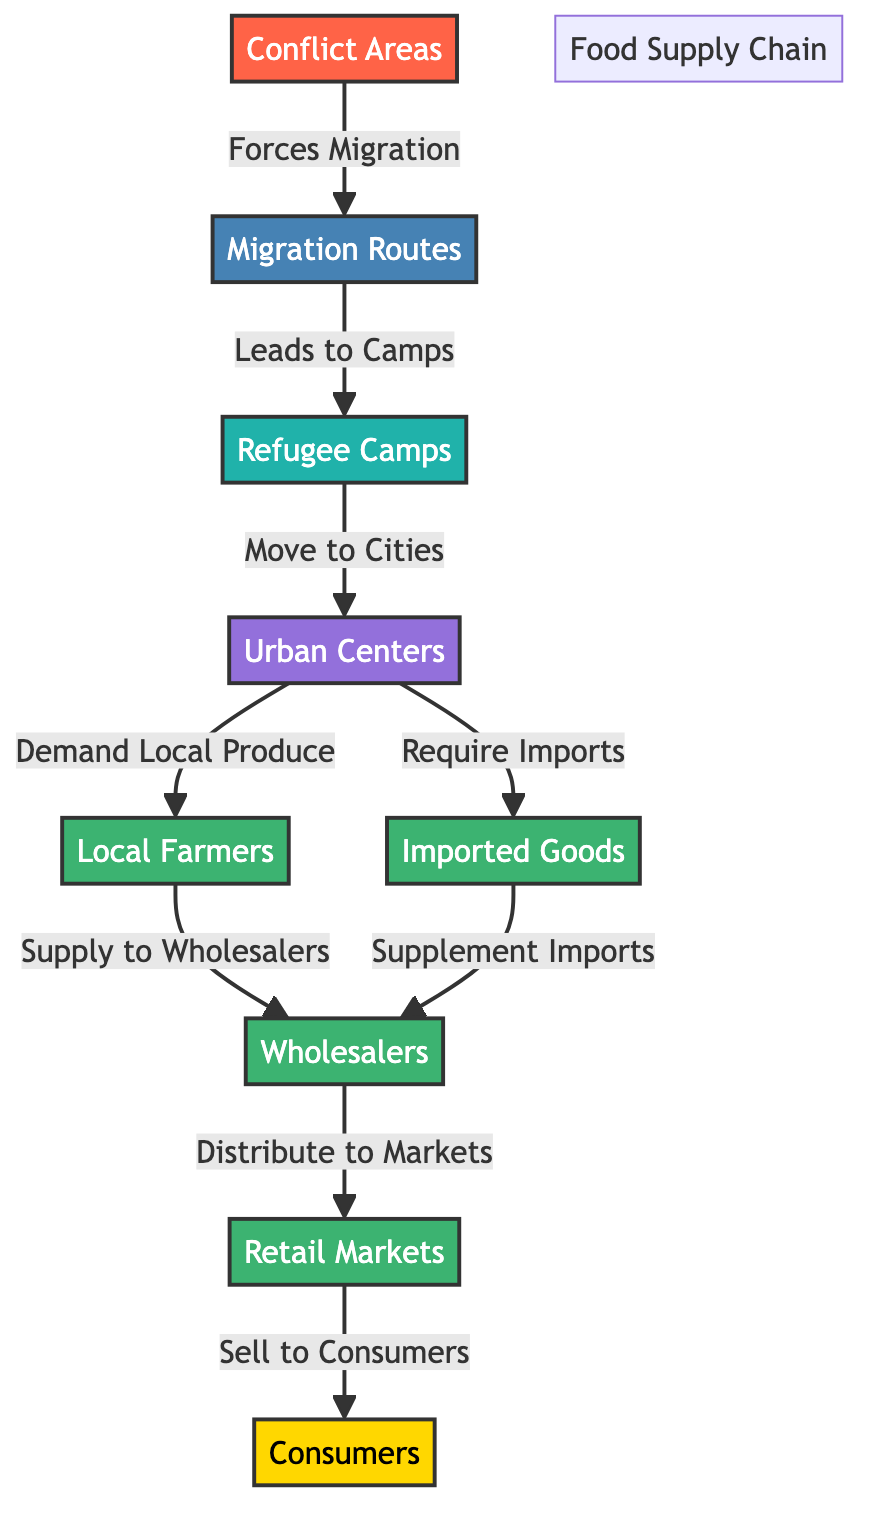What is the starting point of the diagram? The starting point is the "Conflict Areas," which is represented as the source node in the diagram. This node initiates the flow of migration due to conflicts.
Answer: Conflict Areas How many total nodes are present in the diagram? By counting each distinct node represented in the diagram, we find there are a total of eight nodes: Conflict Areas, Migration Routes, Refugee Camps, Urban Centers, Local Farmers, Imported Goods, Wholesalers, Retail Markets, and Consumers.
Answer: Eight What do Refugee Camps lead to? The diagram indicates that Refugee Camps facilitate movement to Urban Centers, as depicted in the directional arrow connecting these two nodes.
Answer: Urban Centers How do Urban Centers obtain food? Urban Centers require food through two pathways shown in the diagram: first, they demand Local Produce from Local Farmers and second, they require Imported Goods. This dual dependency highlights how Urban Centers source food.
Answer: Local Produce and Imported Goods Which node supplies to Wholesalers? According to the diagram, the Local Farmers supply to Wholesalers, as shown by the directional arrow pointing from the Local Farmers node to the Wholesalers node.
Answer: Local Farmers What is the final destination of goods in the food supply chain? The final destination for goods in the diagram is Consumers, who purchase items from Retail Markets. The flow indicates that Retail Markets distribute to Consumers.
Answer: Consumers How do Wholesalers distribute goods according to the diagram? Wholesalers distribute goods to Retail Markets, as indicated by the arrow pointing from the Wholesalers node to the Retail Markets node in the diagram.
Answer: Retail Markets What role do Imported Goods play in this supply chain? Imported Goods supplement the supply of food by providing an additional source for Wholesalers, as illustrated by the arrow connecting Imported Goods to Wholesalers.
Answer: Supplement Imports In what way does Urban Centers affect Local Farmers? The Urban Centers create demand for Local Produce from Local Farmers, which is shown in the diagram with a directed connection highlighting this relationship.
Answer: Demand Local Produce 